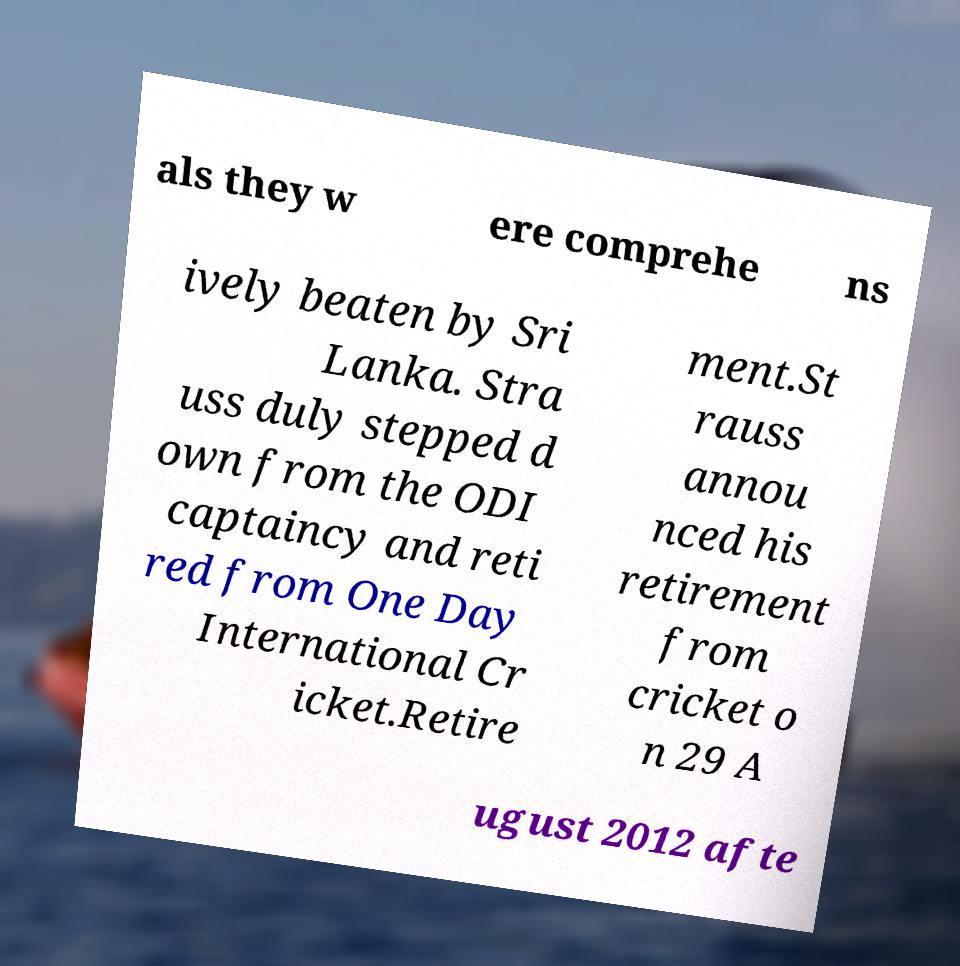Could you assist in decoding the text presented in this image and type it out clearly? als they w ere comprehe ns ively beaten by Sri Lanka. Stra uss duly stepped d own from the ODI captaincy and reti red from One Day International Cr icket.Retire ment.St rauss annou nced his retirement from cricket o n 29 A ugust 2012 afte 